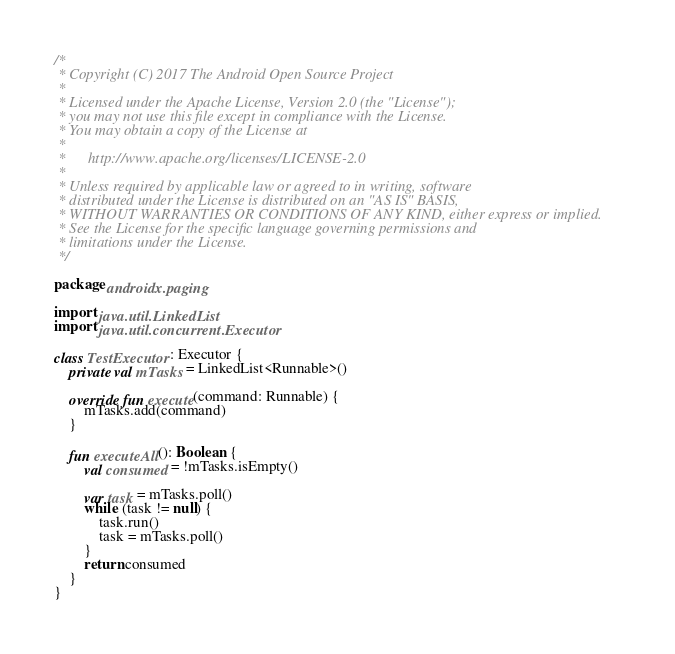<code> <loc_0><loc_0><loc_500><loc_500><_Kotlin_>/*
 * Copyright (C) 2017 The Android Open Source Project
 *
 * Licensed under the Apache License, Version 2.0 (the "License");
 * you may not use this file except in compliance with the License.
 * You may obtain a copy of the License at
 *
 *      http://www.apache.org/licenses/LICENSE-2.0
 *
 * Unless required by applicable law or agreed to in writing, software
 * distributed under the License is distributed on an "AS IS" BASIS,
 * WITHOUT WARRANTIES OR CONDITIONS OF ANY KIND, either express or implied.
 * See the License for the specific language governing permissions and
 * limitations under the License.
 */

package androidx.paging

import java.util.LinkedList
import java.util.concurrent.Executor

class TestExecutor : Executor {
    private val mTasks = LinkedList<Runnable>()

    override fun execute(command: Runnable) {
        mTasks.add(command)
    }

    fun executeAll(): Boolean {
        val consumed = !mTasks.isEmpty()

        var task = mTasks.poll()
        while (task != null) {
            task.run()
            task = mTasks.poll()
        }
        return consumed
    }
}</code> 